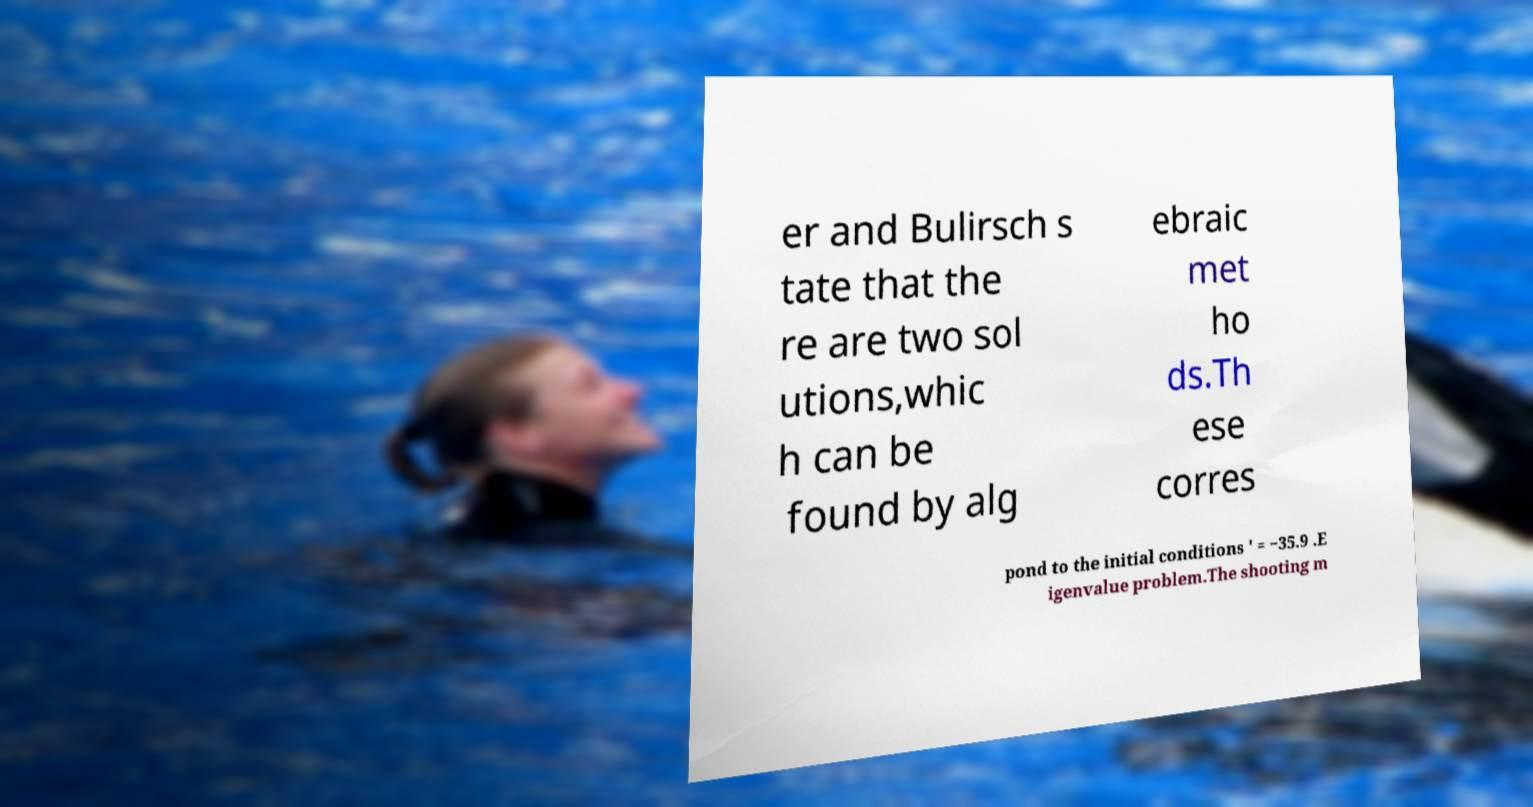Please identify and transcribe the text found in this image. er and Bulirsch s tate that the re are two sol utions,whic h can be found by alg ebraic met ho ds.Th ese corres pond to the initial conditions ′ = −35.9 .E igenvalue problem.The shooting m 